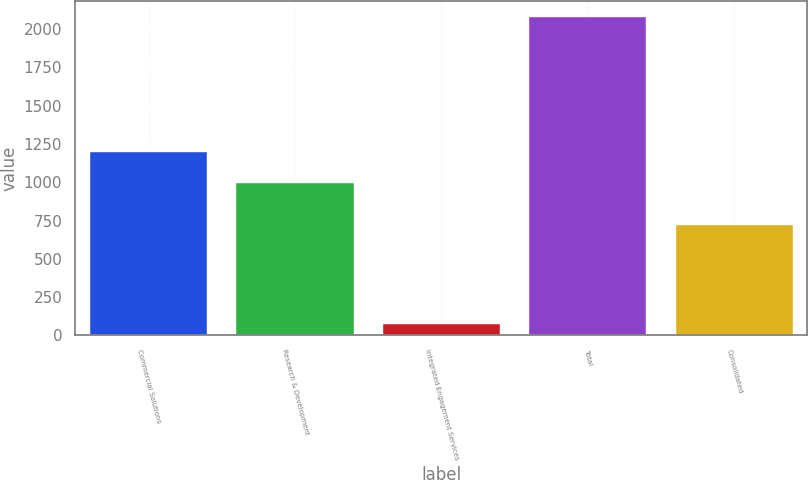Convert chart to OTSL. <chart><loc_0><loc_0><loc_500><loc_500><bar_chart><fcel>Commercial Solutions<fcel>Research & Development<fcel>Integrated Engagement Services<fcel>Total<fcel>Consolidated<nl><fcel>1197.7<fcel>997<fcel>73<fcel>2080<fcel>719<nl></chart> 